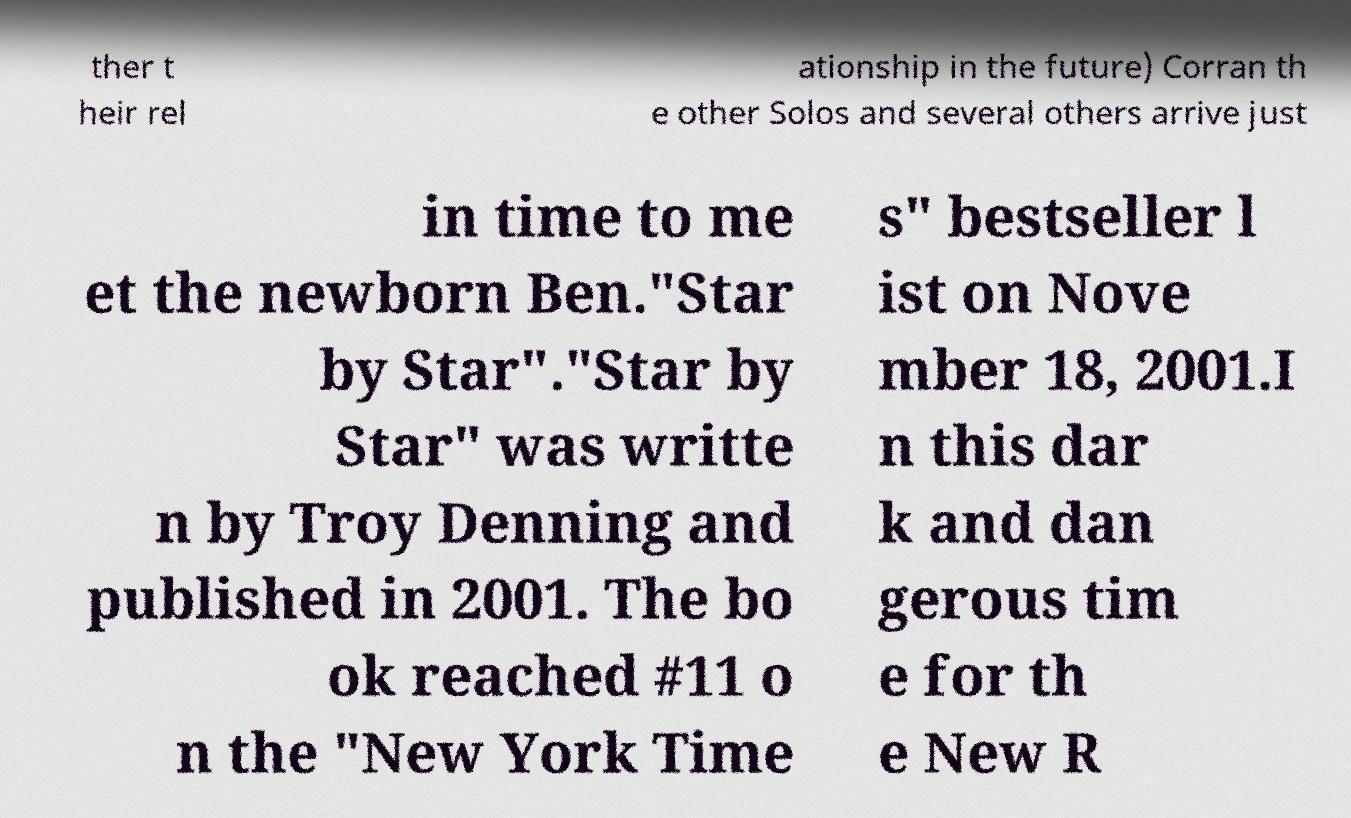For documentation purposes, I need the text within this image transcribed. Could you provide that? ther t heir rel ationship in the future) Corran th e other Solos and several others arrive just in time to me et the newborn Ben."Star by Star"."Star by Star" was writte n by Troy Denning and published in 2001. The bo ok reached #11 o n the "New York Time s" bestseller l ist on Nove mber 18, 2001.I n this dar k and dan gerous tim e for th e New R 